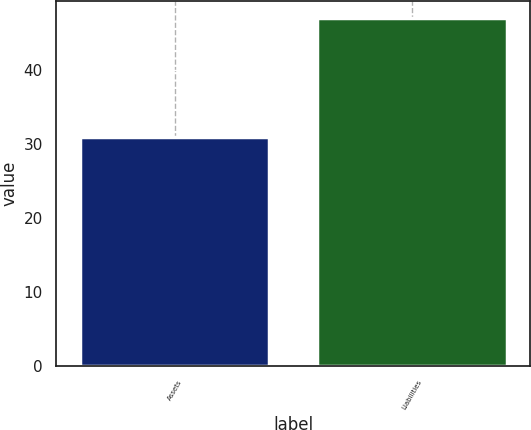<chart> <loc_0><loc_0><loc_500><loc_500><bar_chart><fcel>Assets<fcel>Liabilities<nl><fcel>31<fcel>47<nl></chart> 